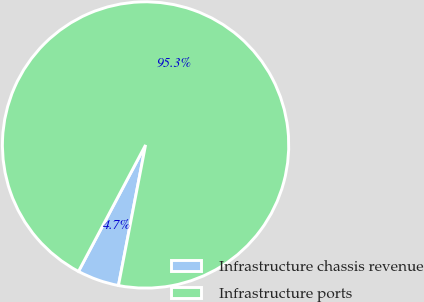Convert chart to OTSL. <chart><loc_0><loc_0><loc_500><loc_500><pie_chart><fcel>Infrastructure chassis revenue<fcel>Infrastructure ports<nl><fcel>4.73%<fcel>95.27%<nl></chart> 